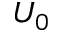<formula> <loc_0><loc_0><loc_500><loc_500>U _ { 0 }</formula> 